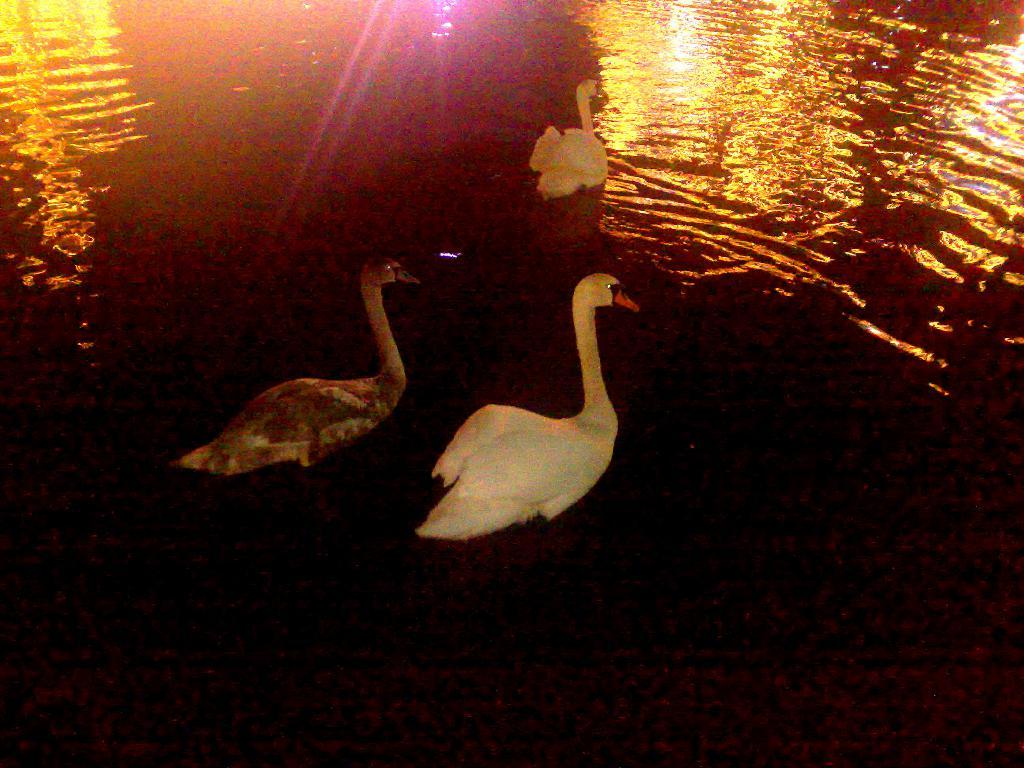What animals are present in the image? There are swans in the image. Where are the swans located? The swans are on the water. What type of paper can be seen in the image? There is no paper present in the image; it features swans on the water. How many noses can be seen on the swans in the image? Swans do not have noses like humans; they have beaks, and there is no way to count them in the image. 